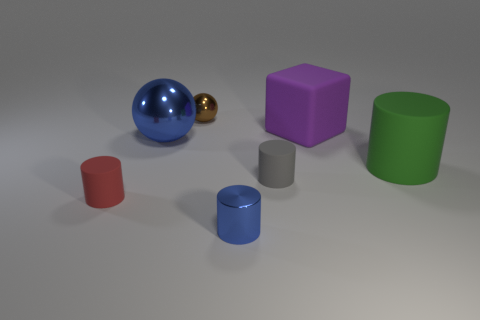How does the size of the green cylinder compare to the other objects? The green cylinder is one of the larger objects in the image. It's taller than the other cylinders, the cube, and considerably larger than the tiny gold ball. It's a dominant visual element due to its size and vibrant color. 